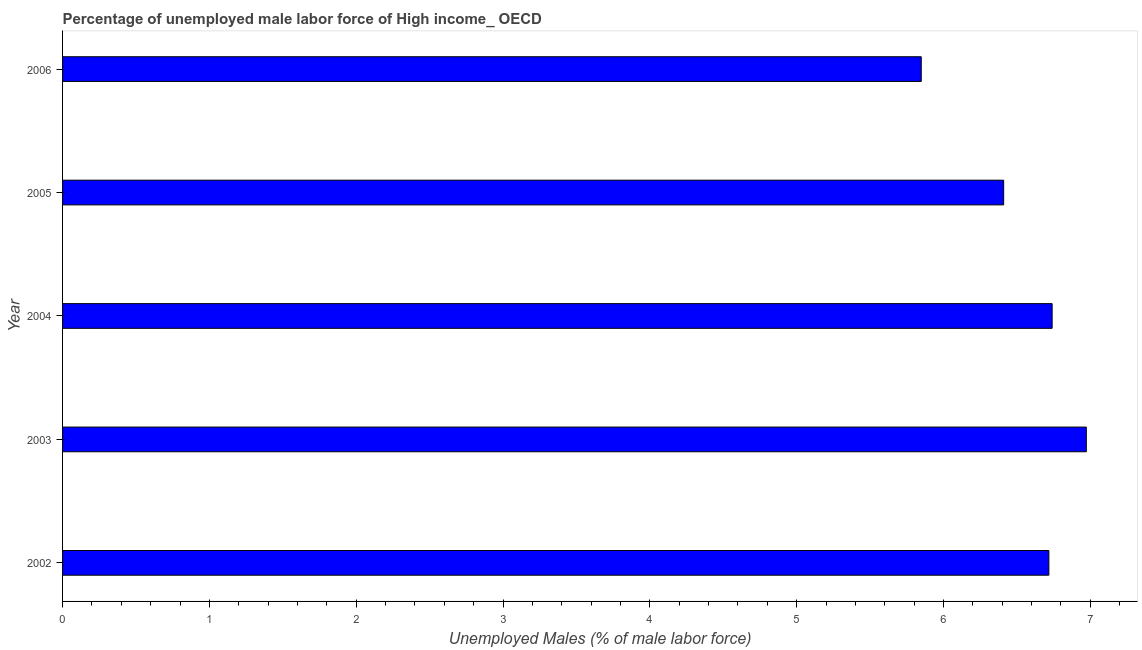What is the title of the graph?
Ensure brevity in your answer.  Percentage of unemployed male labor force of High income_ OECD. What is the label or title of the X-axis?
Provide a short and direct response. Unemployed Males (% of male labor force). What is the label or title of the Y-axis?
Ensure brevity in your answer.  Year. What is the total unemployed male labour force in 2003?
Offer a very short reply. 6.97. Across all years, what is the maximum total unemployed male labour force?
Your answer should be compact. 6.97. Across all years, what is the minimum total unemployed male labour force?
Make the answer very short. 5.85. What is the sum of the total unemployed male labour force?
Make the answer very short. 32.69. What is the difference between the total unemployed male labour force in 2002 and 2006?
Give a very brief answer. 0.87. What is the average total unemployed male labour force per year?
Provide a short and direct response. 6.54. What is the median total unemployed male labour force?
Provide a succinct answer. 6.72. Do a majority of the years between 2002 and 2006 (inclusive) have total unemployed male labour force greater than 1.4 %?
Give a very brief answer. Yes. What is the ratio of the total unemployed male labour force in 2003 to that in 2005?
Provide a succinct answer. 1.09. Is the total unemployed male labour force in 2002 less than that in 2004?
Offer a terse response. Yes. What is the difference between the highest and the second highest total unemployed male labour force?
Keep it short and to the point. 0.23. What is the difference between the highest and the lowest total unemployed male labour force?
Your answer should be very brief. 1.12. In how many years, is the total unemployed male labour force greater than the average total unemployed male labour force taken over all years?
Offer a very short reply. 3. How many bars are there?
Keep it short and to the point. 5. How many years are there in the graph?
Keep it short and to the point. 5. Are the values on the major ticks of X-axis written in scientific E-notation?
Provide a short and direct response. No. What is the Unemployed Males (% of male labor force) of 2002?
Offer a very short reply. 6.72. What is the Unemployed Males (% of male labor force) in 2003?
Offer a terse response. 6.97. What is the Unemployed Males (% of male labor force) in 2004?
Your response must be concise. 6.74. What is the Unemployed Males (% of male labor force) of 2005?
Keep it short and to the point. 6.41. What is the Unemployed Males (% of male labor force) in 2006?
Offer a terse response. 5.85. What is the difference between the Unemployed Males (% of male labor force) in 2002 and 2003?
Your answer should be very brief. -0.25. What is the difference between the Unemployed Males (% of male labor force) in 2002 and 2004?
Your response must be concise. -0.02. What is the difference between the Unemployed Males (% of male labor force) in 2002 and 2005?
Keep it short and to the point. 0.31. What is the difference between the Unemployed Males (% of male labor force) in 2002 and 2006?
Your answer should be very brief. 0.87. What is the difference between the Unemployed Males (% of male labor force) in 2003 and 2004?
Provide a succinct answer. 0.23. What is the difference between the Unemployed Males (% of male labor force) in 2003 and 2005?
Provide a short and direct response. 0.56. What is the difference between the Unemployed Males (% of male labor force) in 2003 and 2006?
Your response must be concise. 1.12. What is the difference between the Unemployed Males (% of male labor force) in 2004 and 2005?
Provide a short and direct response. 0.33. What is the difference between the Unemployed Males (% of male labor force) in 2004 and 2006?
Offer a very short reply. 0.89. What is the difference between the Unemployed Males (% of male labor force) in 2005 and 2006?
Offer a terse response. 0.56. What is the ratio of the Unemployed Males (% of male labor force) in 2002 to that in 2005?
Keep it short and to the point. 1.05. What is the ratio of the Unemployed Males (% of male labor force) in 2002 to that in 2006?
Provide a short and direct response. 1.15. What is the ratio of the Unemployed Males (% of male labor force) in 2003 to that in 2004?
Make the answer very short. 1.03. What is the ratio of the Unemployed Males (% of male labor force) in 2003 to that in 2005?
Provide a succinct answer. 1.09. What is the ratio of the Unemployed Males (% of male labor force) in 2003 to that in 2006?
Offer a terse response. 1.19. What is the ratio of the Unemployed Males (% of male labor force) in 2004 to that in 2005?
Provide a short and direct response. 1.05. What is the ratio of the Unemployed Males (% of male labor force) in 2004 to that in 2006?
Your answer should be very brief. 1.15. What is the ratio of the Unemployed Males (% of male labor force) in 2005 to that in 2006?
Your answer should be very brief. 1.1. 